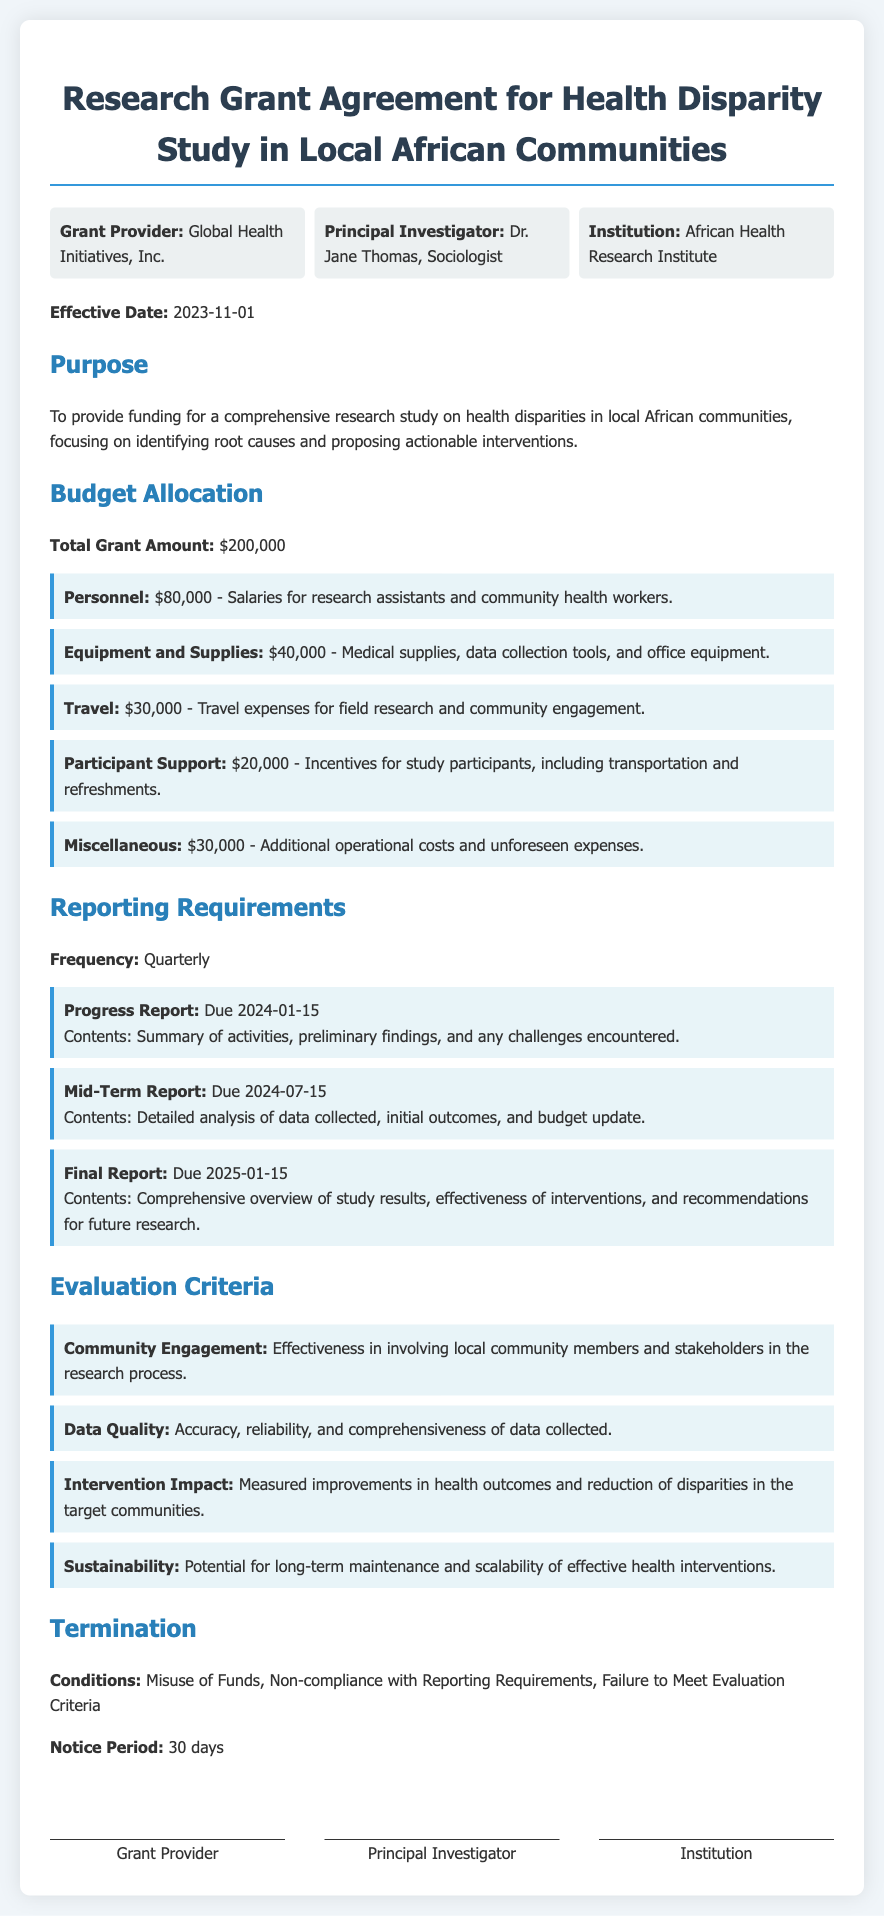What is the effective date of the agreement? The effective date is explicitly stated in the document as "2023-11-01."
Answer: 2023-11-01 Who is the Principal Investigator? The document identifies the Principal Investigator as "Dr. Jane Thomas, Sociologist."
Answer: Dr. Jane Thomas, Sociologist What is the total grant amount? The total grant amount is clearly outlined in the budget section as "$200,000."
Answer: $200,000 When is the Progress Report due? The due date for the Progress Report is listed as "2024-01-15."
Answer: 2024-01-15 What is one of the evaluation criteria? The document lists several evaluation criteria, one being "Community Engagement."
Answer: Community Engagement What is the budget allocation for Personnel? The budget allocation for Personnel is specified as "$80,000."
Answer: $80,000 What is the notice period for termination? The notice period for termination is defined as "30 days."
Answer: 30 days What are the conditions for termination? The conditions for termination are outlined, including "Misuse of Funds."
Answer: Misuse of Funds How frequently are reports required? The frequency of reports is stated as "Quarterly."
Answer: Quarterly 